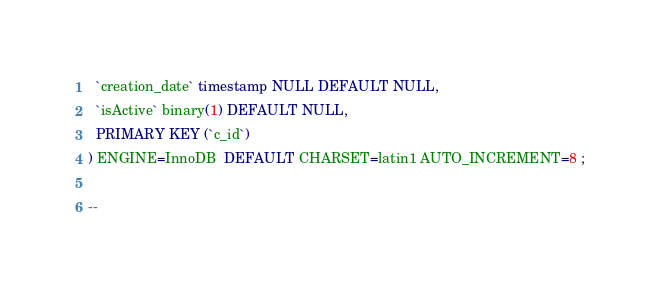Convert code to text. <code><loc_0><loc_0><loc_500><loc_500><_SQL_>  `creation_date` timestamp NULL DEFAULT NULL,
  `isActive` binary(1) DEFAULT NULL,
  PRIMARY KEY (`c_id`)
) ENGINE=InnoDB  DEFAULT CHARSET=latin1 AUTO_INCREMENT=8 ;

--</code> 